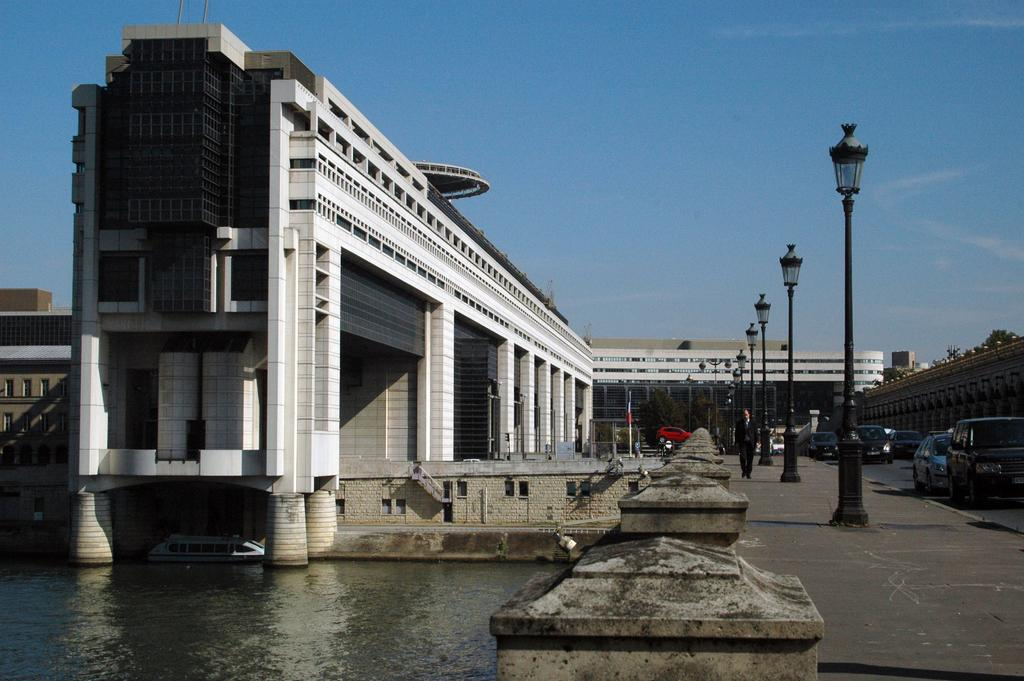What is visible in the image? Water, lights on poles, vehicles, a man walking, buildings, a wall, a tree, and the sky are visible in the image. Can you describe the lights in the image? The lights are on poles in the image. What is the man doing in the image? The man is walking in the image. What can be seen in the background of the image? Buildings, a wall, a tree, and the sky are visible in the background of the image. What type of cushion is being used by the tree in the image? There is no cushion present in the image, and the tree is not using any cushion. How many offices are visible in the image? There are no offices visible in the image. 